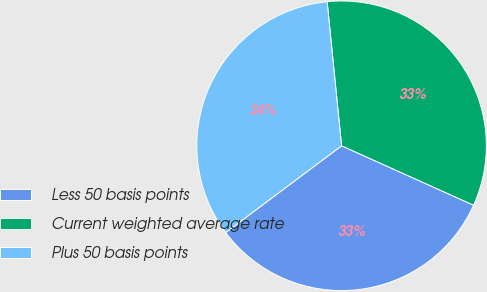Convert chart. <chart><loc_0><loc_0><loc_500><loc_500><pie_chart><fcel>Less 50 basis points<fcel>Current weighted average rate<fcel>Plus 50 basis points<nl><fcel>33.04%<fcel>33.32%<fcel>33.64%<nl></chart> 